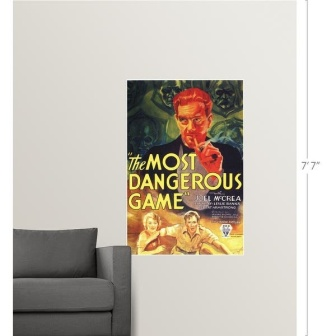Can you describe the ambiance this movie poster creates in the room? The movie poster for 'The Most Dangerous Game' introduces a dynamic and energetic ambiance to the room. The vibrant colors and intense imagery serve as a focal point, infusing the space with a sense of anticipation and excitement. The contrast between the bold visuals and the neutral tones of the gray couch enhances the poster's prominence, creating a balanced yet stimulating visual composition. This combination reflects a cinematic theme, making the room feel like a stylish and modern homage to classic thrillers, perfect for a movie enthusiast or someone who appreciates intriguing artwork. Could this image be a part of a larger collection of similar artworks? What themes might be explored? Absolutely, the image of 'The Most Dangerous Game' movie poster could very well be part of a curated collection of vintage or classic movie posters. Such a collection might explore themes of adventure, suspense, and the golden age of cinema. It could include posters from iconic films that defined genres like horror, thriller, and adventure, featuring enigmatic titles, dramatic illustrations, and notable figures from cinema history. Themes of human survival, the psychological battle of wit and strength, and tales of intrigue could be prominently showcased, providing a window into the rich narrative traditions of classic storytelling. For instance, the collection might also feature posters of movies like 'King Kong,' 'Dracula,' or 'Frankenstein,' each bringing a unique, thrilling, and nostalgic element to the overall decor. Imagine a fantastical scenario where the characters from this poster come to life. What happens next? In a fantastical scenario where the characters from 'The Most Dangerous Game' movie poster come to life, the room transforms into the treacherous island featured in their story. The man with the red face, revealed to be the cunning and enigmatic Count Zaroff, steps out of the poster, instantly filling the room with an air of tension and thrill. He begins to strategize, turning the once serene living space into a hunting ground, his intense gaze fixed on his prey. Following him are Joel McCrea's character, the resilient and resourceful Rainsford, and Fay Wray's Eve, both emerging with a mix of determination and fear. As they navigate the transformed jungle-like environment, the lines between reality and fiction blur, creating a spellbinding arena where survival is paramount. The adventure unfolds with dramatic confrontations, clever traps, and a race against time, turning the ordinary room into a stage for an extraordinary and perilous game. 